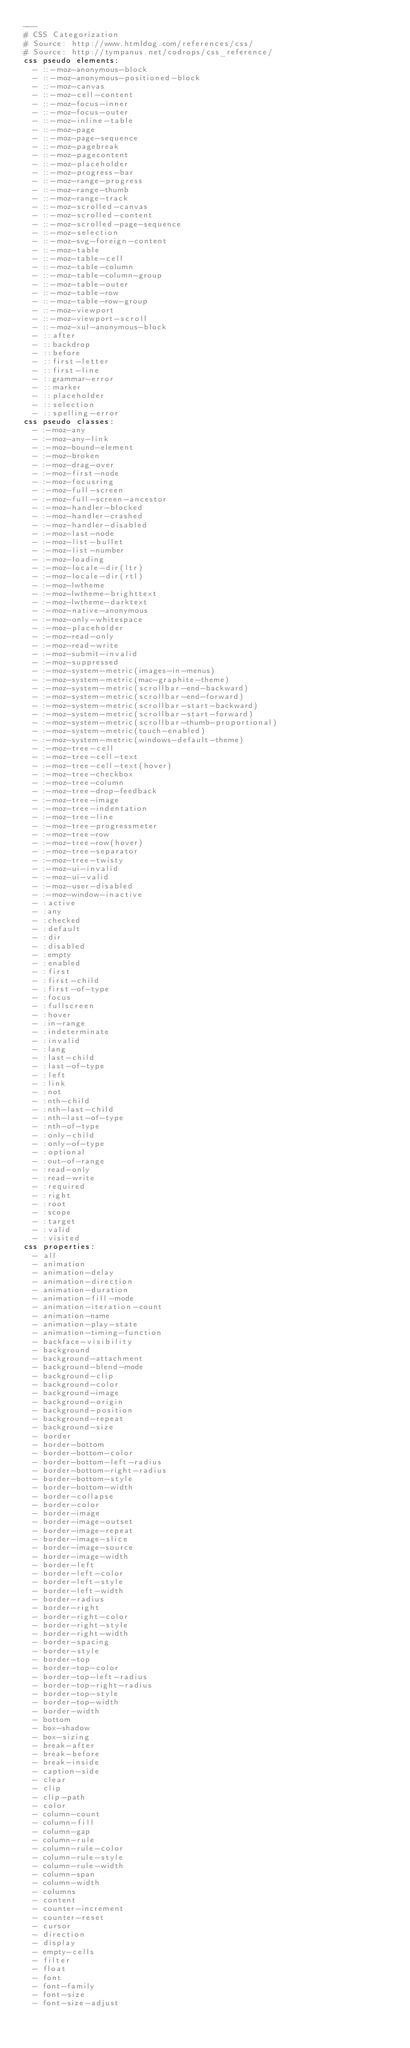Convert code to text. <code><loc_0><loc_0><loc_500><loc_500><_YAML_>---
# CSS Categorization
# Source: http://www.htmldog.com/references/css/
# Source: http://tympanus.net/codrops/css_reference/
css pseudo elements:
  - ::-moz-anonymous-block
  - ::-moz-anonymous-positioned-block
  - ::-moz-canvas
  - ::-moz-cell-content
  - ::-moz-focus-inner
  - ::-moz-focus-outer
  - ::-moz-inline-table
  - ::-moz-page
  - ::-moz-page-sequence
  - ::-moz-pagebreak
  - ::-moz-pagecontent
  - ::-moz-placeholder
  - ::-moz-progress-bar
  - ::-moz-range-progress
  - ::-moz-range-thumb
  - ::-moz-range-track
  - ::-moz-scrolled-canvas
  - ::-moz-scrolled-content
  - ::-moz-scrolled-page-sequence
  - ::-moz-selection
  - ::-moz-svg-foreign-content
  - ::-moz-table
  - ::-moz-table-cell
  - ::-moz-table-column
  - ::-moz-table-column-group
  - ::-moz-table-outer
  - ::-moz-table-row
  - ::-moz-table-row-group
  - ::-moz-viewport
  - ::-moz-viewport-scroll
  - ::-moz-xul-anonymous-block
  - ::after
  - ::backdrop
  - ::before
  - ::first-letter
  - ::first-line
  - ::grammar-error
  - ::marker
  - ::placeholder
  - ::selection
  - ::spelling-error
css pseudo classes:
  - :-moz-any
  - :-moz-any-link
  - :-moz-bound-element
  - :-moz-broken
  - :-moz-drag-over
  - :-moz-first-node
  - :-moz-focusring
  - :-moz-full-screen
  - :-moz-full-screen-ancestor
  - :-moz-handler-blocked
  - :-moz-handler-crashed
  - :-moz-handler-disabled
  - :-moz-last-node
  - :-moz-list-bullet
  - :-moz-list-number
  - :-moz-loading
  - :-moz-locale-dir(ltr)
  - :-moz-locale-dir(rtl)
  - :-moz-lwtheme
  - :-moz-lwtheme-brighttext
  - :-moz-lwtheme-darktext
  - :-moz-native-anonymous
  - :-moz-only-whitespace
  - :-moz-placeholder
  - :-moz-read-only
  - :-moz-read-write
  - :-moz-submit-invalid
  - :-moz-suppressed
  - :-moz-system-metric(images-in-menus)
  - :-moz-system-metric(mac-graphite-theme)
  - :-moz-system-metric(scrollbar-end-backward)
  - :-moz-system-metric(scrollbar-end-forward)
  - :-moz-system-metric(scrollbar-start-backward)
  - :-moz-system-metric(scrollbar-start-forward)
  - :-moz-system-metric(scrollbar-thumb-proportional)
  - :-moz-system-metric(touch-enabled)
  - :-moz-system-metric(windows-default-theme)
  - :-moz-tree-cell
  - :-moz-tree-cell-text
  - :-moz-tree-cell-text(hover)
  - :-moz-tree-checkbox
  - :-moz-tree-column
  - :-moz-tree-drop-feedback
  - :-moz-tree-image
  - :-moz-tree-indentation
  - :-moz-tree-line
  - :-moz-tree-progressmeter
  - :-moz-tree-row
  - :-moz-tree-row(hover)
  - :-moz-tree-separator
  - :-moz-tree-twisty
  - :-moz-ui-invalid
  - :-moz-ui-valid
  - :-moz-user-disabled
  - :-moz-window-inactive
  - :active
  - :any
  - :checked
  - :default
  - :dir
  - :disabled
  - :empty
  - :enabled
  - :first
  - :first-child
  - :first-of-type
  - :focus
  - :fullscreen
  - :hover
  - :in-range
  - :indeterminate
  - :invalid
  - :lang
  - :last-child
  - :last-of-type
  - :left
  - :link
  - :not
  - :nth-child
  - :nth-last-child
  - :nth-last-of-type
  - :nth-of-type
  - :only-child
  - :only-of-type
  - :optional
  - :out-of-range
  - :read-only
  - :read-write
  - :required
  - :right
  - :root
  - :scope
  - :target
  - :valid
  - :visited
css properties:
  - all
  - animation
  - animation-delay
  - animation-direction
  - animation-duration
  - animation-fill-mode
  - animation-iteration-count
  - animation-name
  - animation-play-state
  - animation-timing-function
  - backface-visibility
  - background
  - background-attachment
  - background-blend-mode
  - background-clip
  - background-color
  - background-image
  - background-origin
  - background-position
  - background-repeat
  - background-size
  - border
  - border-bottom
  - border-bottom-color
  - border-bottom-left-radius
  - border-bottom-right-radius
  - border-bottom-style
  - border-bottom-width
  - border-collapse
  - border-color
  - border-image
  - border-image-outset
  - border-image-repeat
  - border-image-slice
  - border-image-source
  - border-image-width
  - border-left
  - border-left-color
  - border-left-style
  - border-left-width
  - border-radius
  - border-right
  - border-right-color
  - border-right-style
  - border-right-width
  - border-spacing
  - border-style
  - border-top
  - border-top-color
  - border-top-left-radius
  - border-top-right-radius
  - border-top-style
  - border-top-width
  - border-width
  - bottom
  - box-shadow
  - box-sizing
  - break-after
  - break-before
  - break-inside
  - caption-side
  - clear
  - clip
  - clip-path
  - color
  - column-count
  - column-fill
  - column-gap
  - column-rule
  - column-rule-color
  - column-rule-style
  - column-rule-width
  - column-span
  - column-width
  - columns
  - content
  - counter-increment
  - counter-reset
  - cursor
  - direction
  - display
  - empty-cells
  - filter
  - float
  - font
  - font-family
  - font-size
  - font-size-adjust</code> 